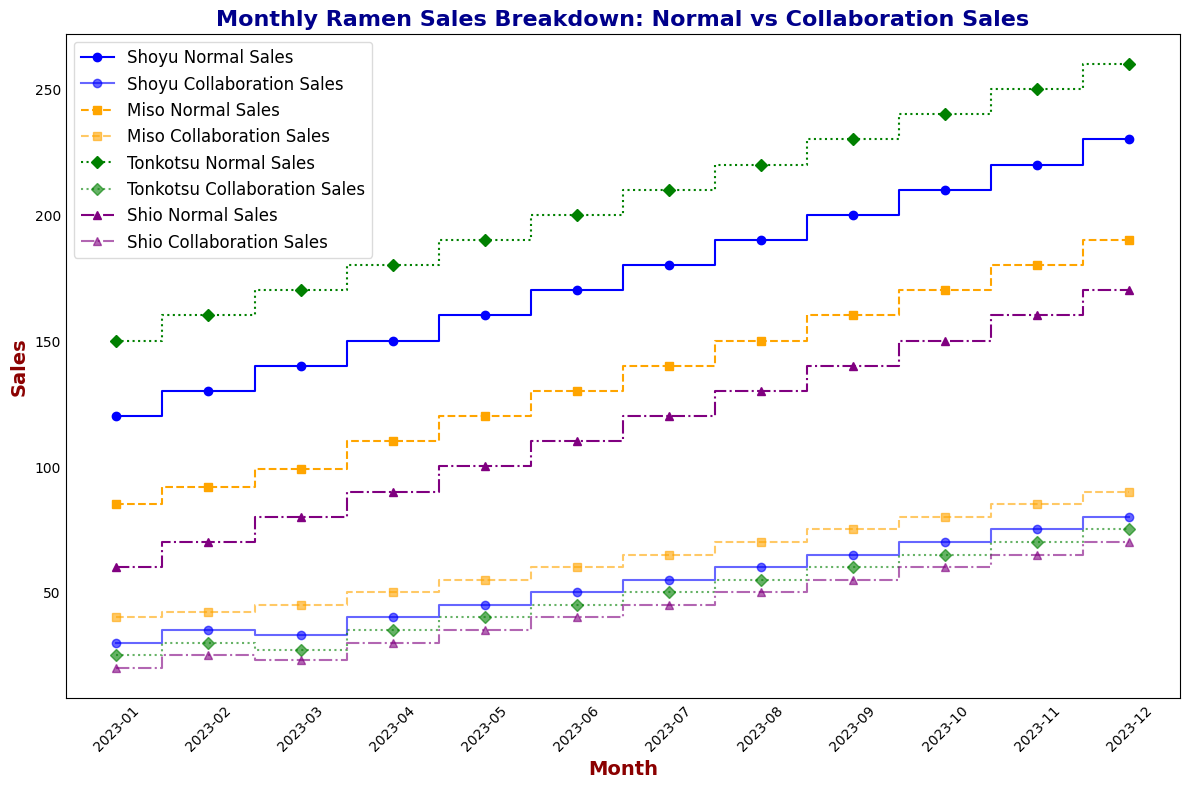Which flavor had the highest total sales in January? To find this, sum the Normal Sales and Collaboration Sales for each flavor in January. For Shoyu: 120 + 30 = 150, Miso: 85 + 40 = 125, Tonkotsu: 150 + 25 = 175, Shio: 60 + 20 = 80. Tonkotsu has the highest total sales in January.
Answer: Tonkotsu How did Miso's collaboration sales in December compare to its normal sales? Look at the plot for December. Miso has 190 normal sales and 90 collaboration sales. Compare the two values to see that the normal sales are higher than collaboration sales.
Answer: Normal sales are higher Which month saw the highest sales for Shoyu collaboration flavors? Examine the steps for Shoyu collaboration sales over the months. The highest point visually corresponds to December with 80 collaboration sales.
Answer: December What is the difference between normal and collaboration sales for Shio in April? In April, Shio has 90 normal sales and 30 collaboration sales. Calculate the difference: 90 - 30.
Answer: 60 Which flavor increased the most in total sales from January to December? Calculate the total sales for each flavor in January and December, subtract January totals from December totals and compare. Shoyu: (230+80)-(120+30)=160, Miso: (190+90)-(85+40)=155, Tonkotsu: (260+75)-(150+25)=160, Shio: (170+70)-(60+20)=160. Shoyu, Tonkotsu, and Shio all increased by 160.
Answer: Shoyu, Tonkotsu, and Shio Did any flavor have the same collaboration sales as normal sales in any month? Check the plot for all months and flavors. No steps align for both collaboration and normal sales on any flavor in any given month.
Answer: No What was the average monthly collaboration sales for Miso in the third quarter? Third quarter includes July, August, and September. Miso collaboration sales are 65, 70, and 75. Calculate the average: (65 + 70 + 75) / 3 = 210 / 3.
Answer: 70 How did the total sales of Shio in July compare to the total sales of Tonkotsu in the same month? Sum up July's normal and collaboration sales for both: Shio: 120 + 45 = 165, Tonkotsu: 210 + 50 = 260. Compare the totals.
Answer: Tonkotsu's were higher Which month saw the smallest difference between normal and collaboration sales for any flavor? Examine differences month by month. The smallest difference, which is 5, appears for April (Miso: 110 - 105).
Answer: April Which flavor showed consistent growth in collaboration sales month over month? Check the collaboration sales steps for each flavor to see if they consistently rise. Miso's collaboration sales increase every month, showing consistent growth.
Answer: Miso 